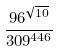<formula> <loc_0><loc_0><loc_500><loc_500>\frac { 9 6 ^ { \sqrt { 1 0 } } } { 3 0 9 ^ { 4 4 6 } }</formula> 